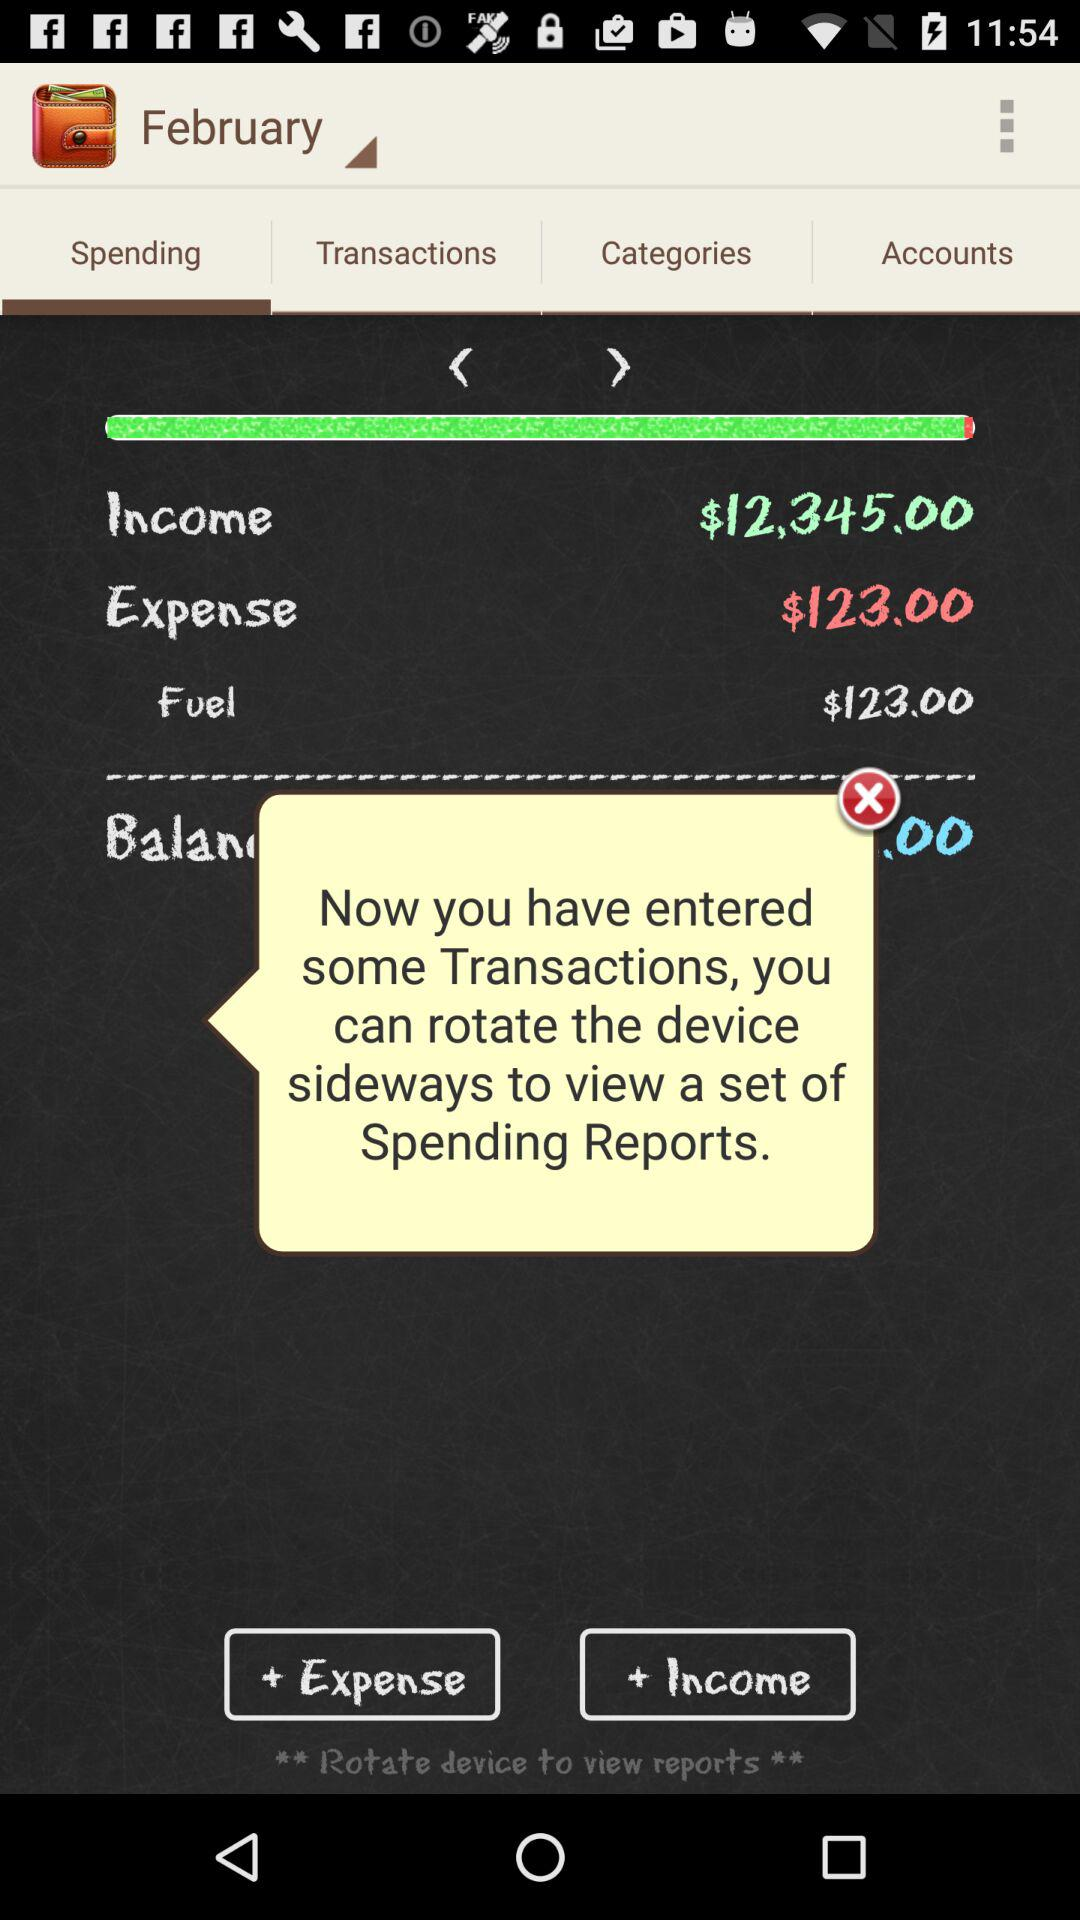Which month's spending is shown? The month is February. 